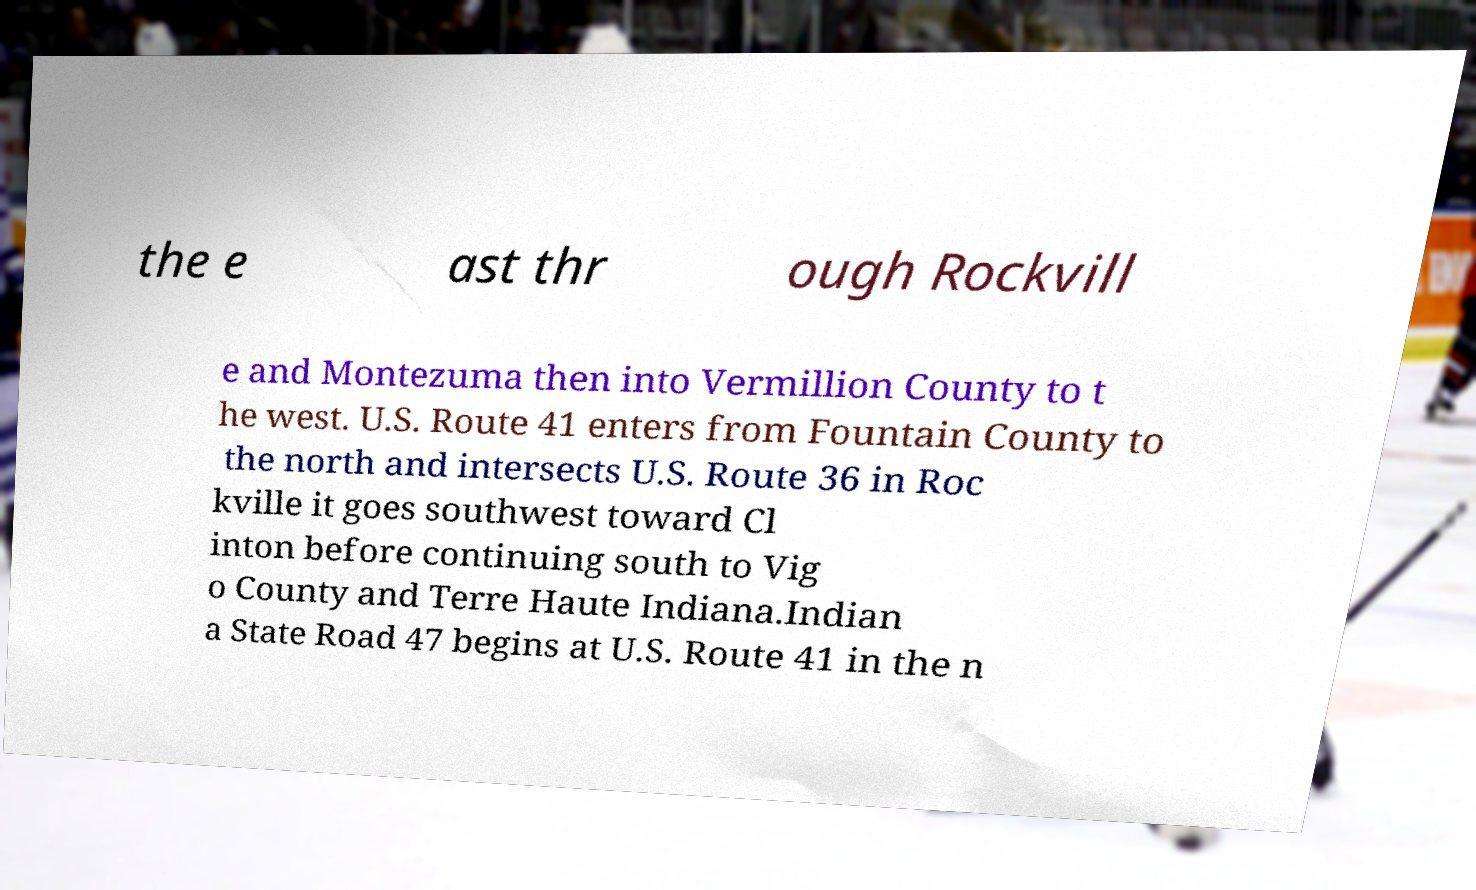Can you accurately transcribe the text from the provided image for me? the e ast thr ough Rockvill e and Montezuma then into Vermillion County to t he west. U.S. Route 41 enters from Fountain County to the north and intersects U.S. Route 36 in Roc kville it goes southwest toward Cl inton before continuing south to Vig o County and Terre Haute Indiana.Indian a State Road 47 begins at U.S. Route 41 in the n 